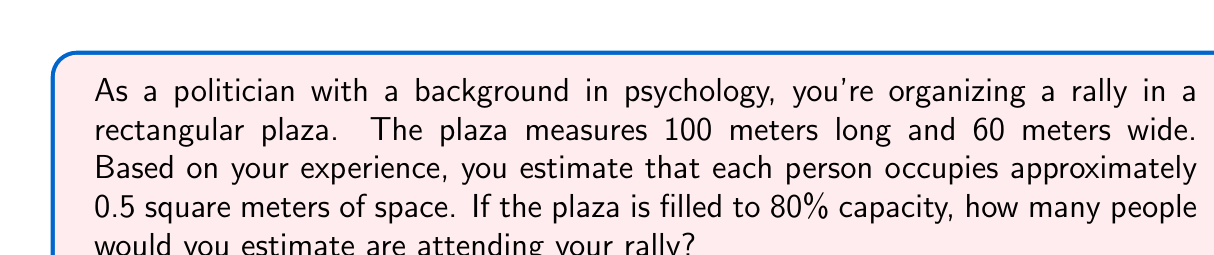Teach me how to tackle this problem. To solve this problem, we'll follow these steps:

1. Calculate the total area of the plaza:
   $$A_{total} = length \times width = 100 \text{ m} \times 60 \text{ m} = 6000 \text{ m}^2$$

2. Calculate the area occupied at 80% capacity:
   $$A_{occupied} = A_{total} \times 80\% = 6000 \text{ m}^2 \times 0.8 = 4800 \text{ m}^2$$

3. Calculate the number of people that can fit in the occupied area:
   $$N_{people} = \frac{A_{occupied}}{A_{per person}} = \frac{4800 \text{ m}^2}{0.5 \text{ m}^2/person}$$

4. Simplify and solve:
   $$N_{people} = 4800 \text{ m}^2 \times \frac{1 \text{ person}}{0.5 \text{ m}^2} = 9600 \text{ people}$$

[asy]
size(200,120);
draw((0,0)--(100,0)--(100,60)--(0,60)--cycle);
label("100 m", (50,0), S);
label("60 m", (100,30), E);
fill((0,0)--(100,0)--(100,60)--(0,60)--cycle, opacity(0.2));
[/asy]

This method of estimation using geometric area calculations is a common technique used in crowd size estimation. As a politician with a psychology background, you understand the importance of accurate crowd size estimates for both logistical planning and public perception. However, it's important to note that this is still an estimate and actual attendance may vary due to factors such as crowd density variations and movement patterns.
Answer: The estimated crowd size at the political rally is 9,600 people. 